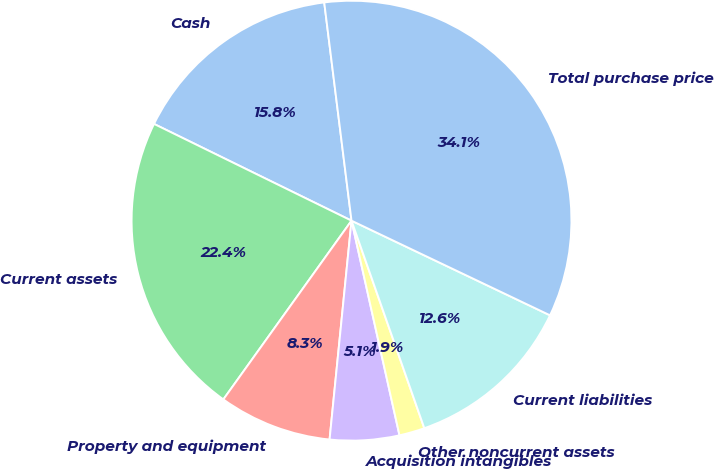Convert chart to OTSL. <chart><loc_0><loc_0><loc_500><loc_500><pie_chart><fcel>Cash<fcel>Current assets<fcel>Property and equipment<fcel>Acquisition intangibles<fcel>Other noncurrent assets<fcel>Current liabilities<fcel>Total purchase price<nl><fcel>15.77%<fcel>22.35%<fcel>8.31%<fcel>5.09%<fcel>1.87%<fcel>12.55%<fcel>34.06%<nl></chart> 